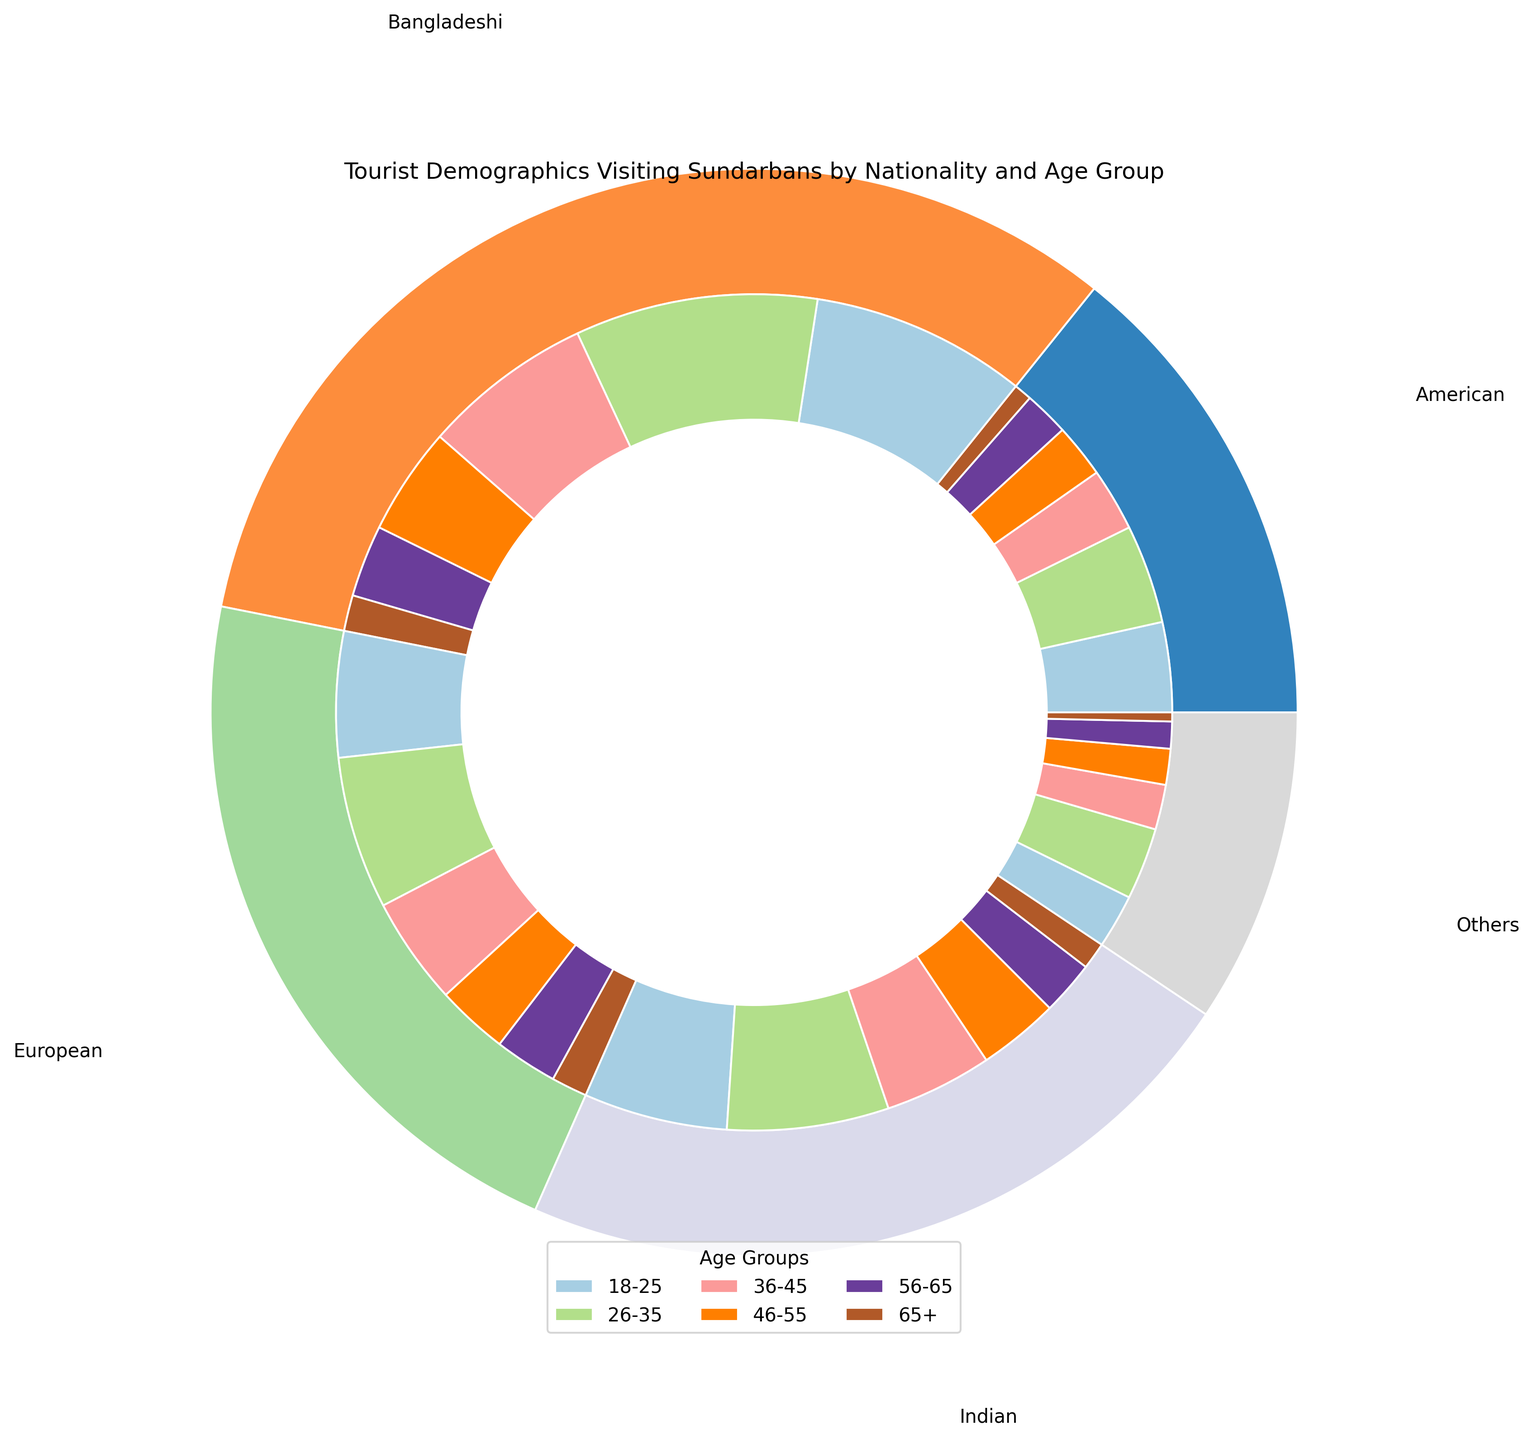Which nationality has the highest number of tourists aged 18-25? By observing the inner ring of the pie chart, identify the color section that corresponds to the 18-25 age group. Compare the sizes of these sections for the different nationalities.
Answer: Bangladeshi What is the total number of tourists from European nationality? Add the number of tourists from all age groups for the European nationality: 70 (18-25) + 85 (26-35) + 60 (36-45) + 40 (46-55) + 35 (56-65) + 20 (65+).
Answer: 310 How does the number of Indian tourists aged 36-45 compare to the number of American tourists aged 36-45? Locate the sections for the 36-45 age group in the inner ring. Compare the size of the Indian (60) section to that of the American (35) section.
Answer: Indian > American What is the percentage of Bangladeshi tourists aged 46-55 among all Bangladeshi tourists? Calculate the piece's proportion by dividing the number of Bangladeshi tourists aged 46-55 (60) by the total number of Bangladeshi tourists: 120 + 135 + 95 + 60 + 40 + 20 = 470. Percentage is (60 / 470) * 100 ≈ 12.77%.
Answer: ~12.77% Which age group has the least number of tourists across all nationalities? Sum the number of tourists for each age group across all nationalities and identify the smallest sum.
Answer: 65+ Compare the total number of tourists aged 18-25 and 26-35 from all nationalities. Which group has more? Sum the number of tourists aged 18-25: 120 + 80 + 50 + 70 + 30 = 350. Sum the number of tourists aged 26-35: 135 + 90 + 55 + 85 + 40 = 405. Compare the sums.
Answer: 26-35 > 18-25 Which nationality has the smallest representation in the 56-65 age group? Identify the section for the 56-65 age group in the inner ring and find the nationality with the smallest section (Others).
Answer: Others 